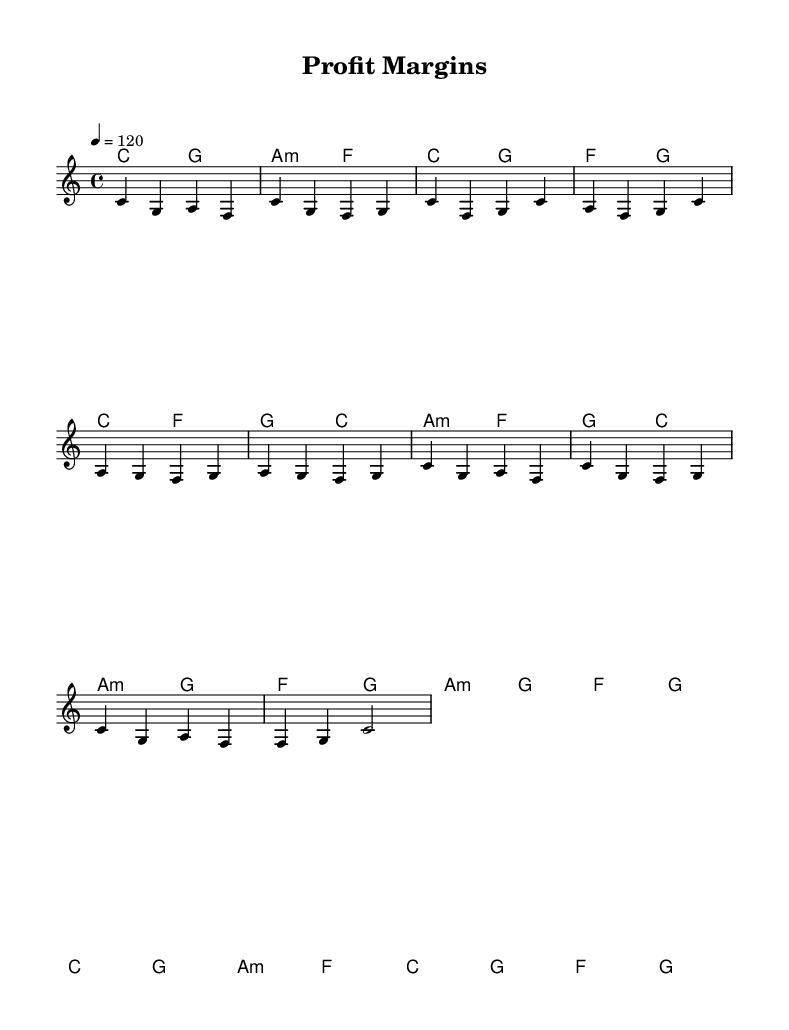What is the key signature of this music? The key signature is C major, which has no sharps or flats.
Answer: C major What is the time signature of this music? The time signature is indicated as 4/4, meaning there are four beats in each measure.
Answer: 4/4 What is the tempo marking for this piece? The tempo marking is indicated as "4 = 120", which means there are 120 beats per minute.
Answer: 120 How many measures are in the chorus section? The chorus section has a total of 4 measures, as indicated by counting the measures in that section of the score.
Answer: 4 Which theme is most prominently expressed in the lyrics? The lyrics focus on business success and financial goals, highlighting concepts like investment and profit margins.
Answer: Business success What types of chords are used in the pre-chorus section? The pre-chorus section utilizes minor chords, specifically indicated as a minor chord (a:m) and major chords.
Answer: Minor chords How does the chorus differ melodically from the verse? The chorus features a repeated melodic pattern that emphasizes a soaring theme compared to the verse’s more varied melody.
Answer: Repeated melodic pattern 